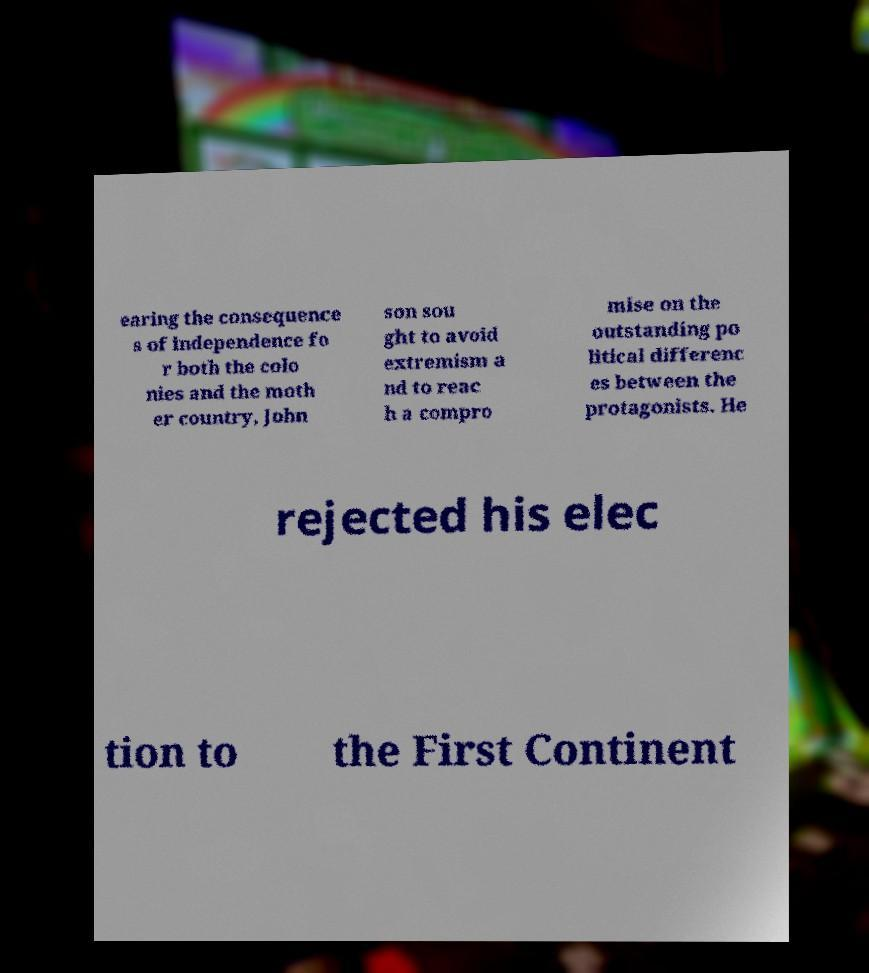Can you accurately transcribe the text from the provided image for me? earing the consequence s of independence fo r both the colo nies and the moth er country, John son sou ght to avoid extremism a nd to reac h a compro mise on the outstanding po litical differenc es between the protagonists. He rejected his elec tion to the First Continent 